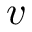Convert formula to latex. <formula><loc_0><loc_0><loc_500><loc_500>v</formula> 